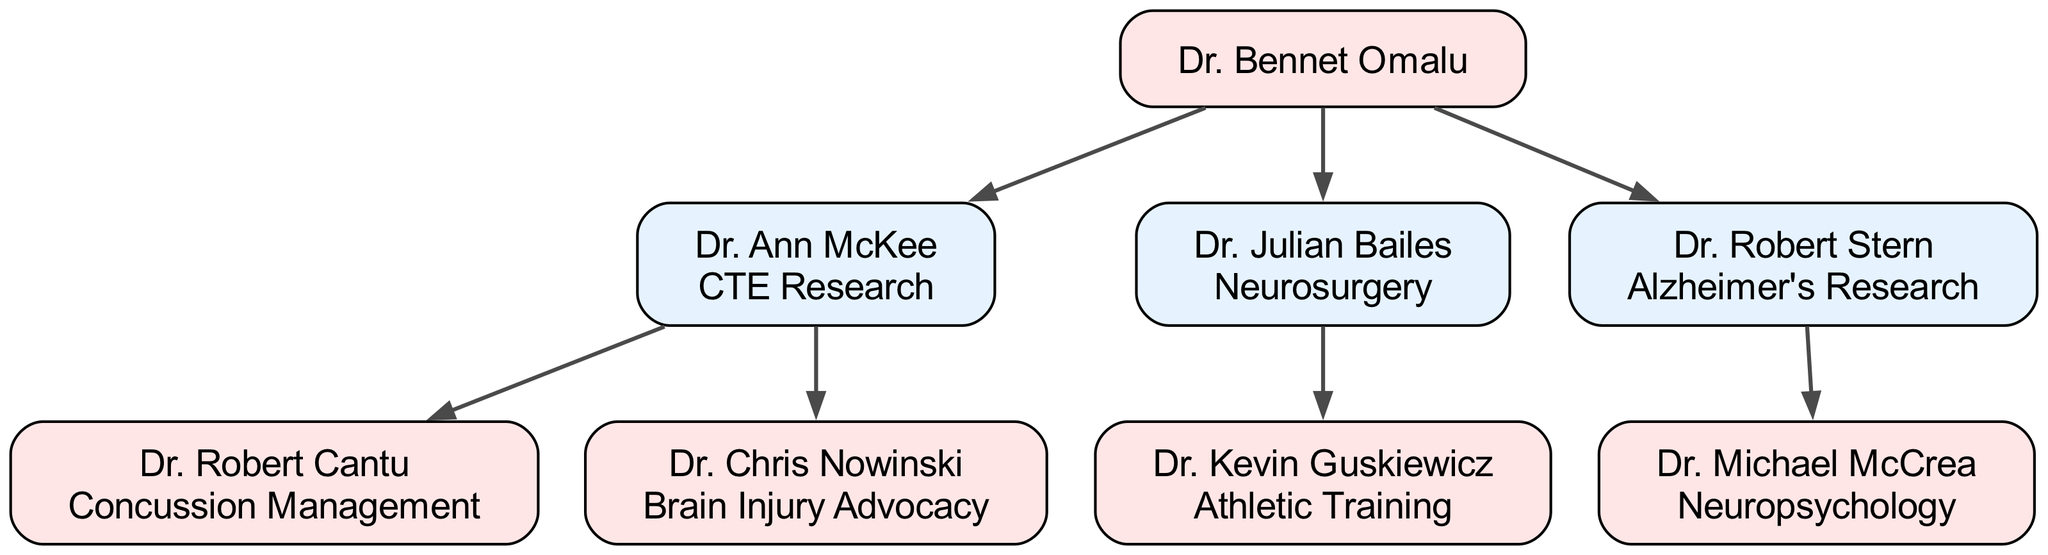What is the specialty of Dr. Ann McKee? Dr. Ann McKee is listed as a child of Dr. Bennet Omalu, and her specialty is explicitly mentioned in the diagram as "CTE Research."
Answer: CTE Research How many children does Dr. Bennet Omalu have? Dr. Bennet Omalu, the root of the family tree, has three children listed: Dr. Ann McKee, Dr. Julian Bailes, and Dr. Robert Stern. Thus, the total number is three.
Answer: 3 Who specializes in Concussion Management? Looking at Dr. Ann McKee's children, Dr. Robert Cantu is specifically mentioned as specializing in "Concussion Management."
Answer: Dr. Robert Cantu Which doctor has a child specializing in Neuropsychology? Dr. Robert Stern has a child, Dr. Michael McCrea, whose specialty is "Neuropsychology," which makes Dr. Robert Stern the answer to this question.
Answer: Dr. Robert Stern What is the specialty of Dr. Julian Bailes' child? Dr. Julian Bailes has one child, Dr. Kevin Guskiewicz, whose specialty is "Athletic Training," as indicated in the diagram.
Answer: Athletic Training How many nodes are present in this family tree? The family tree includes Dr. Bennet Omalu (root), his three children (Dr. Ann McKee, Dr. Julian Bailes, Dr. Robert Stern), and their respective children (Dr. Robert Cantu, Dr. Chris Nowinski, Dr. Kevin Guskiewicz, Dr. Michael McCrea). Thus, there are a total of seven nodes.
Answer: 7 Which doctor is at the top of the family tree? The root node of the family tree, indicated as the starting point, is Dr. Bennet Omalu, and he is positioned at the top of the diagram.
Answer: Dr. Bennet Omalu What is Dr. Robert Stern's specialty? Dr. Robert Stern is identified as specializing in "Alzheimer's Research" within the family tree diagram. This is explicitly mentioned next to his name.
Answer: Alzheimer's Research Who is the child of Dr. Ann McKee that focuses on Brain Injury Advocacy? Specifically listed as a child of Dr. Ann McKee, Dr. Chris Nowinski specializes in "Brain Injury Advocacy." Therefore, he is the answer to this question.
Answer: Dr. Chris Nowinski 